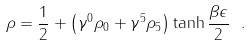Convert formula to latex. <formula><loc_0><loc_0><loc_500><loc_500>\rho = \frac { 1 } { 2 } + \left ( \gamma ^ { 0 } \rho _ { 0 } + \gamma ^ { 5 } \rho _ { 5 } \right ) \tanh \frac { \beta \epsilon } { 2 } \ .</formula> 